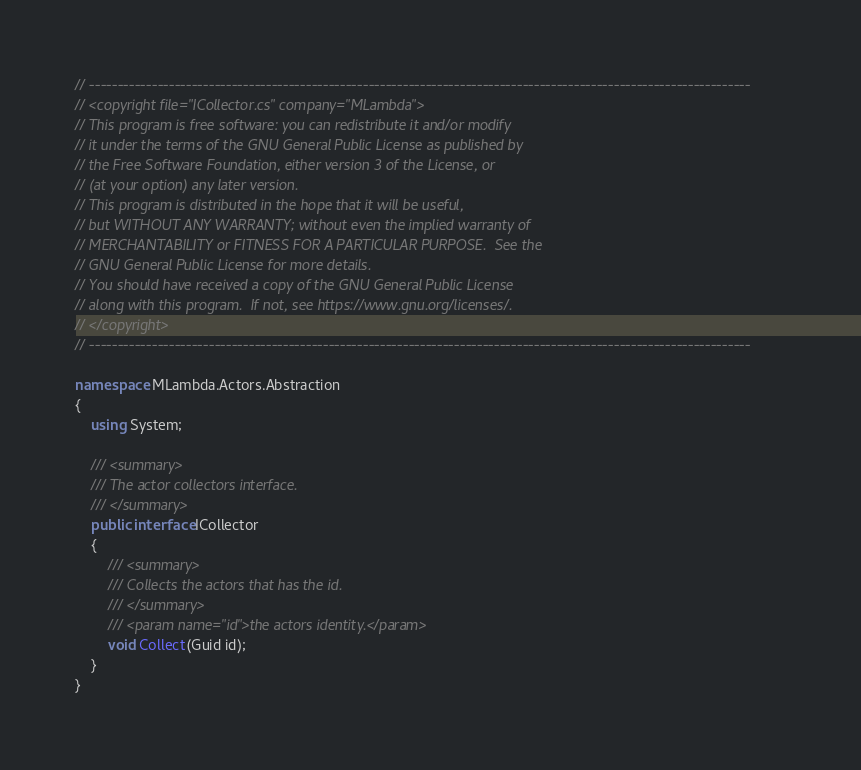<code> <loc_0><loc_0><loc_500><loc_500><_C#_>// --------------------------------------------------------------------------------------------------------------------
// <copyright file="ICollector.cs" company="MLambda">
// This program is free software: you can redistribute it and/or modify
// it under the terms of the GNU General Public License as published by
// the Free Software Foundation, either version 3 of the License, or
// (at your option) any later version.
// This program is distributed in the hope that it will be useful,
// but WITHOUT ANY WARRANTY; without even the implied warranty of
// MERCHANTABILITY or FITNESS FOR A PARTICULAR PURPOSE.  See the
// GNU General Public License for more details.
// You should have received a copy of the GNU General Public License
// along with this program.  If not, see https://www.gnu.org/licenses/.
// </copyright>
// --------------------------------------------------------------------------------------------------------------------

namespace MLambda.Actors.Abstraction
{
    using System;

    /// <summary>
    /// The actor collectors interface.
    /// </summary>
    public interface ICollector
    {
        /// <summary>
        /// Collects the actors that has the id.
        /// </summary>
        /// <param name="id">the actors identity.</param>
        void Collect(Guid id);
    }
}</code> 